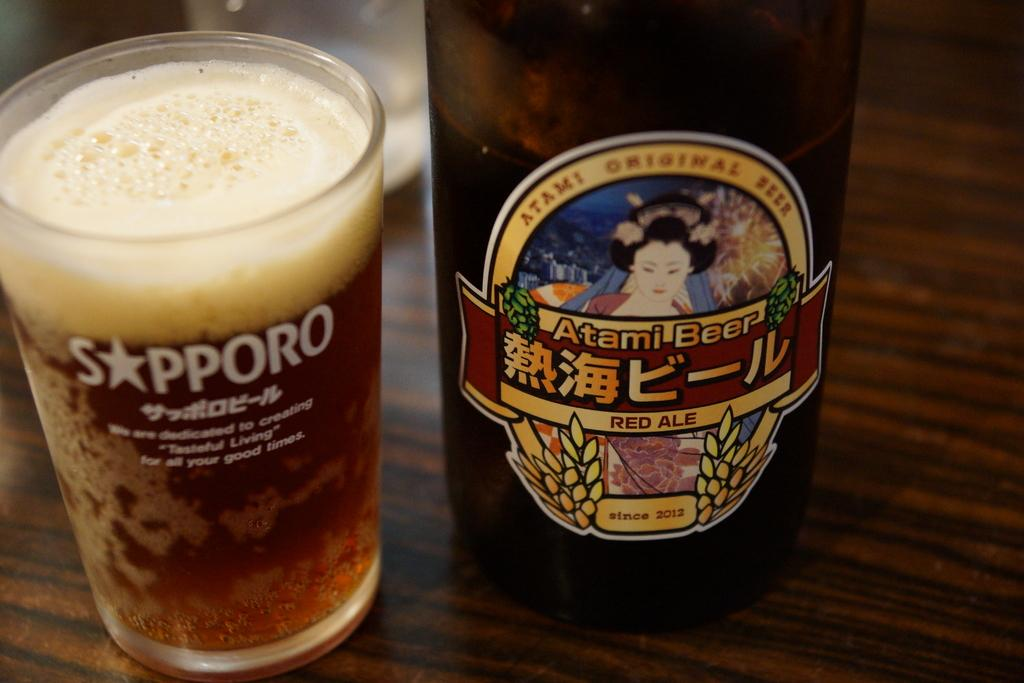<image>
Summarize the visual content of the image. A drinking glass from Sapporo is next to a bottle of red ale. 